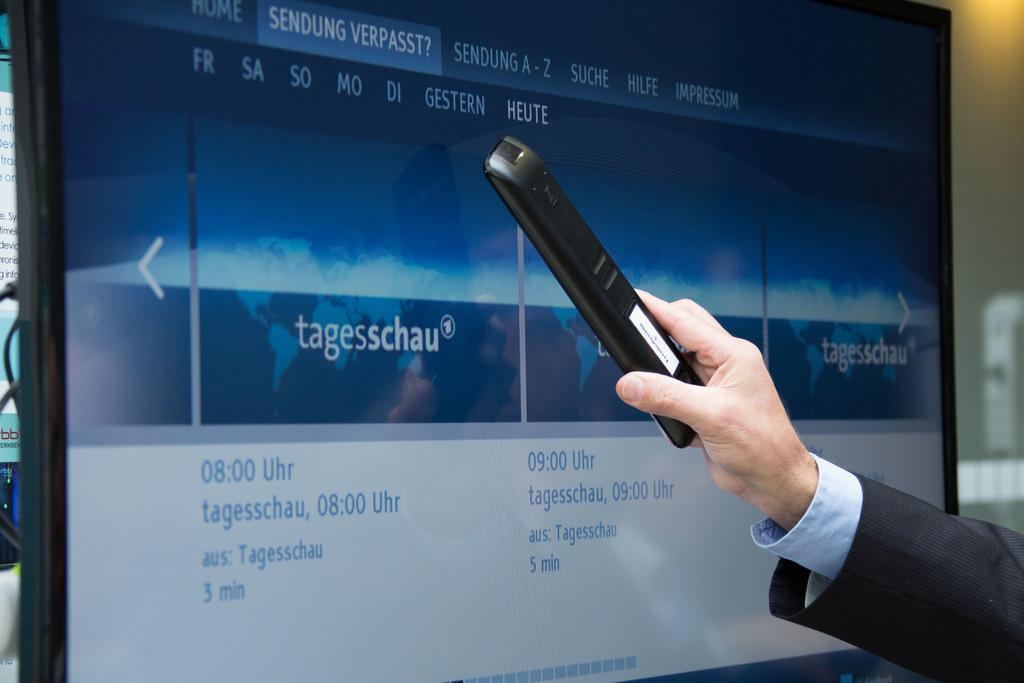Describe this image in one or two sentences. On the right side of this image I can see a person's hand holding a remote. In the background there is a screen on which I can see some text. In the background there is a wall. 